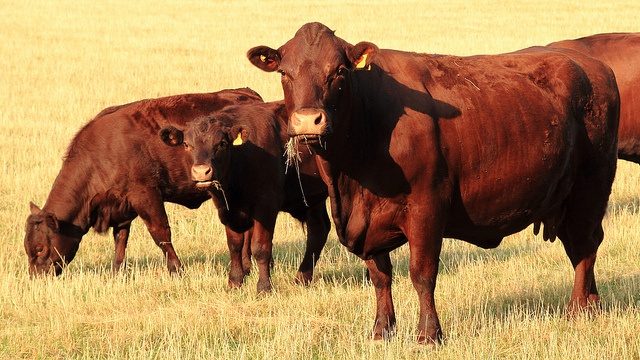Describe the objects in this image and their specific colors. I can see cow in khaki, black, maroon, and brown tones, cow in khaki, maroon, brown, and black tones, cow in khaki, black, maroon, and brown tones, and cow in khaki, brown, salmon, and maroon tones in this image. 